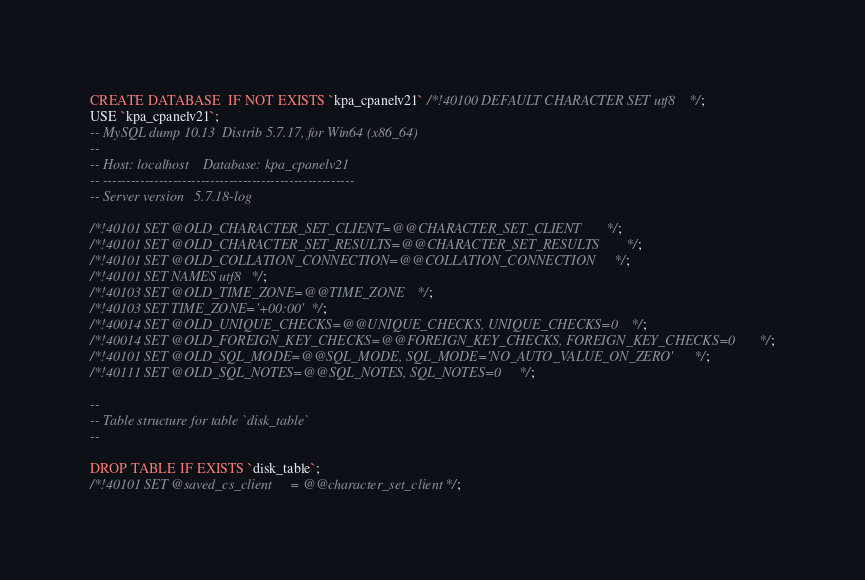Convert code to text. <code><loc_0><loc_0><loc_500><loc_500><_SQL_>CREATE DATABASE  IF NOT EXISTS `kpa_cpanelv21` /*!40100 DEFAULT CHARACTER SET utf8 */;
USE `kpa_cpanelv21`;
-- MySQL dump 10.13  Distrib 5.7.17, for Win64 (x86_64)
--
-- Host: localhost    Database: kpa_cpanelv21
-- ------------------------------------------------------
-- Server version	5.7.18-log

/*!40101 SET @OLD_CHARACTER_SET_CLIENT=@@CHARACTER_SET_CLIENT */;
/*!40101 SET @OLD_CHARACTER_SET_RESULTS=@@CHARACTER_SET_RESULTS */;
/*!40101 SET @OLD_COLLATION_CONNECTION=@@COLLATION_CONNECTION */;
/*!40101 SET NAMES utf8 */;
/*!40103 SET @OLD_TIME_ZONE=@@TIME_ZONE */;
/*!40103 SET TIME_ZONE='+00:00' */;
/*!40014 SET @OLD_UNIQUE_CHECKS=@@UNIQUE_CHECKS, UNIQUE_CHECKS=0 */;
/*!40014 SET @OLD_FOREIGN_KEY_CHECKS=@@FOREIGN_KEY_CHECKS, FOREIGN_KEY_CHECKS=0 */;
/*!40101 SET @OLD_SQL_MODE=@@SQL_MODE, SQL_MODE='NO_AUTO_VALUE_ON_ZERO' */;
/*!40111 SET @OLD_SQL_NOTES=@@SQL_NOTES, SQL_NOTES=0 */;

--
-- Table structure for table `disk_table`
--

DROP TABLE IF EXISTS `disk_table`;
/*!40101 SET @saved_cs_client     = @@character_set_client */;</code> 